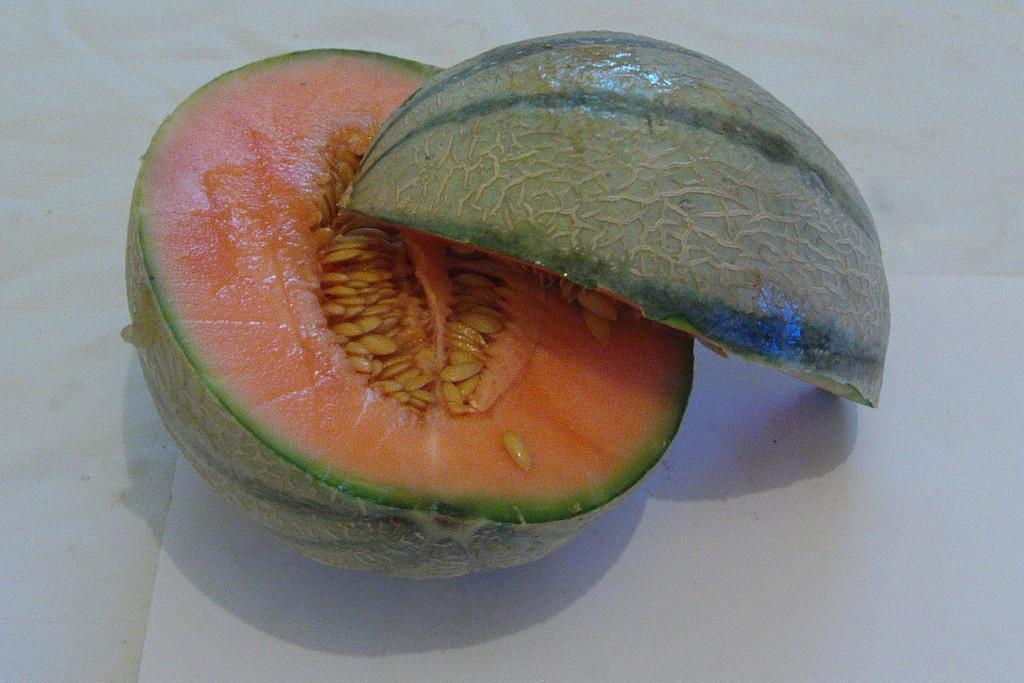Can you describe this image briefly? In this image we can see two pieces of a fruit on the surface. 